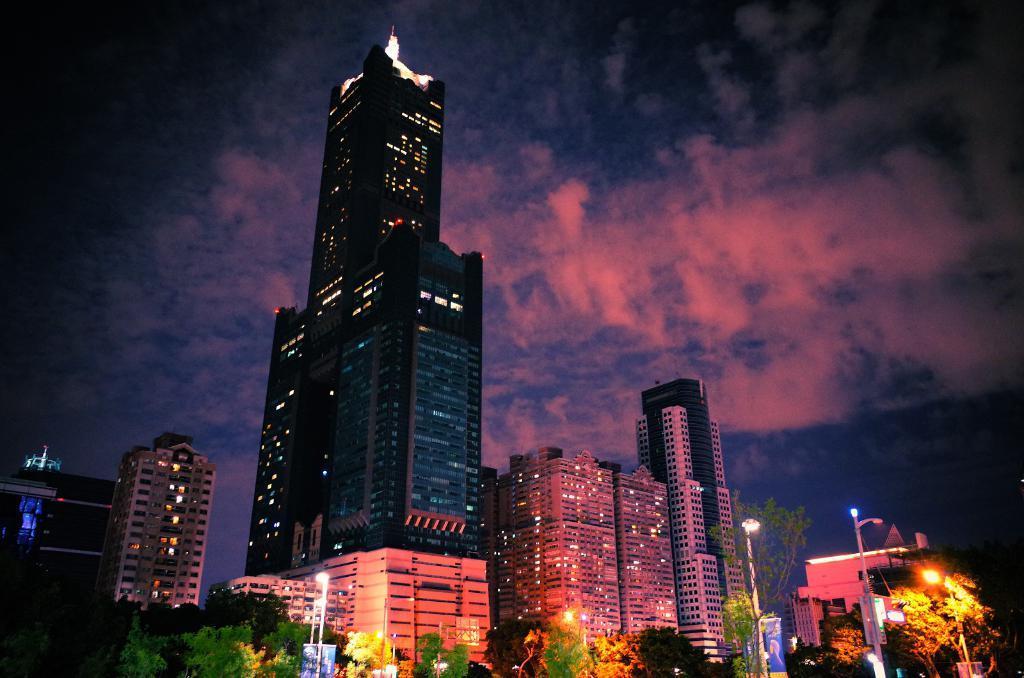Describe this image in one or two sentences. In this image there are buildings and skyscrapers. At the bottom there are trees and street light poles. At the top there is the sky. 